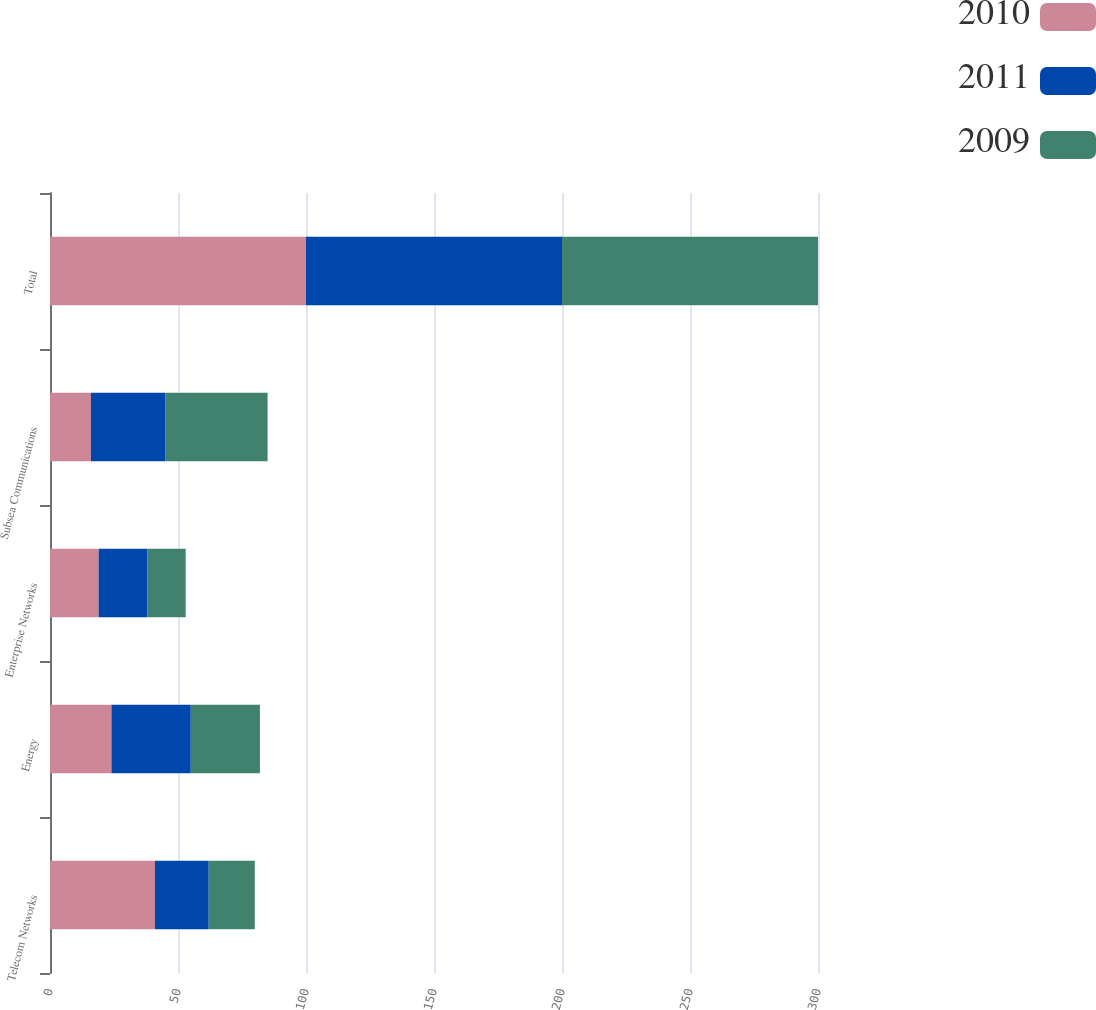<chart> <loc_0><loc_0><loc_500><loc_500><stacked_bar_chart><ecel><fcel>Telecom Networks<fcel>Energy<fcel>Enterprise Networks<fcel>Subsea Communications<fcel>Total<nl><fcel>2010<fcel>41<fcel>24<fcel>19<fcel>16<fcel>100<nl><fcel>2011<fcel>21<fcel>31<fcel>19<fcel>29<fcel>100<nl><fcel>2009<fcel>18<fcel>27<fcel>15<fcel>40<fcel>100<nl></chart> 